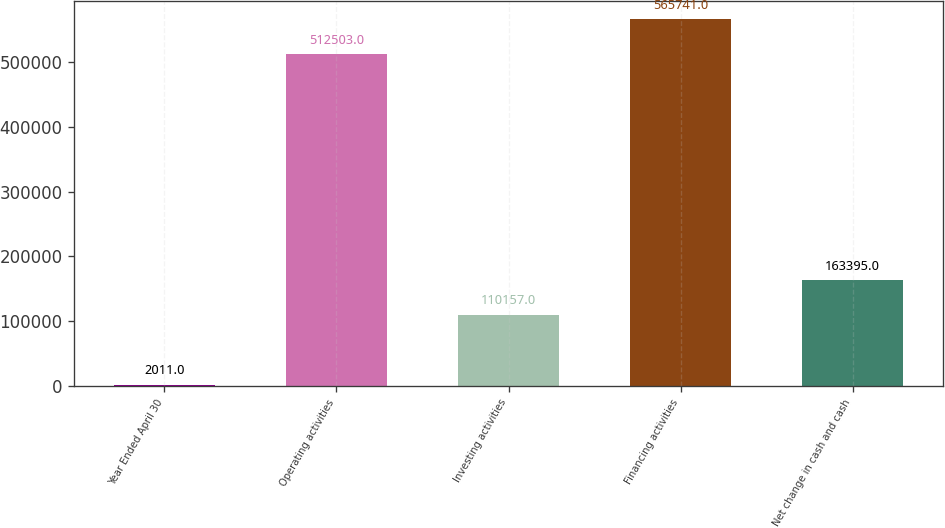<chart> <loc_0><loc_0><loc_500><loc_500><bar_chart><fcel>Year Ended April 30<fcel>Operating activities<fcel>Investing activities<fcel>Financing activities<fcel>Net change in cash and cash<nl><fcel>2011<fcel>512503<fcel>110157<fcel>565741<fcel>163395<nl></chart> 